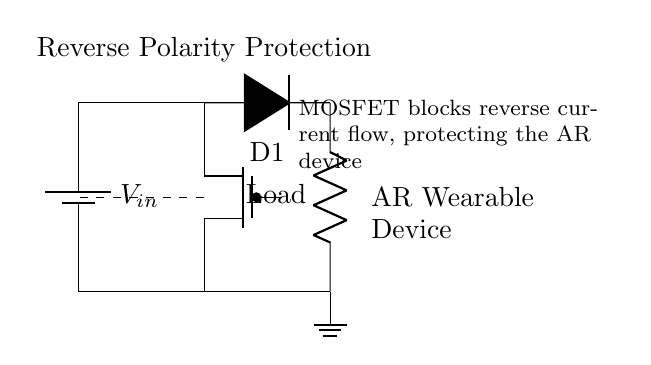What type of diode is used in this circuit? The circuit diagram specifies the component labeled D1, which is indicated as a diode. The notation 'D*' generally represents a standard diode in circuit symbols.
Answer: Diode What is the purpose of the MOSFET in this circuit? The diagram shows a Tpmos labeled as 'pmos'. The role of a PMOS is to allow current to flow when the gate is activated correctly, and it blocks reverse current, thus providing reverse polarity protection for the connected load.
Answer: Protection What component connects the power source to the MOSFET? In the circuit, the connection from the battery to the MOSFET (Tpmos) is made directly with a line, indicating a direct connection from the source voltage.
Answer: Battery What is the load in this circuit? The component labeled 'Load' is a resistor, implying that the load of the circuit is a resistive element that draws power from the circuit output.
Answer: Resistor How does the reverse current protection work? The PMOS transistor blocks reverse current flow when the input voltage is connected in reverse, thanks to its operational characteristics. If the voltage is applied correctly, it allows current to pass through. The diode also prevents current from flowing back to the source in case of reverse connection.
Answer: PMOS and diode 